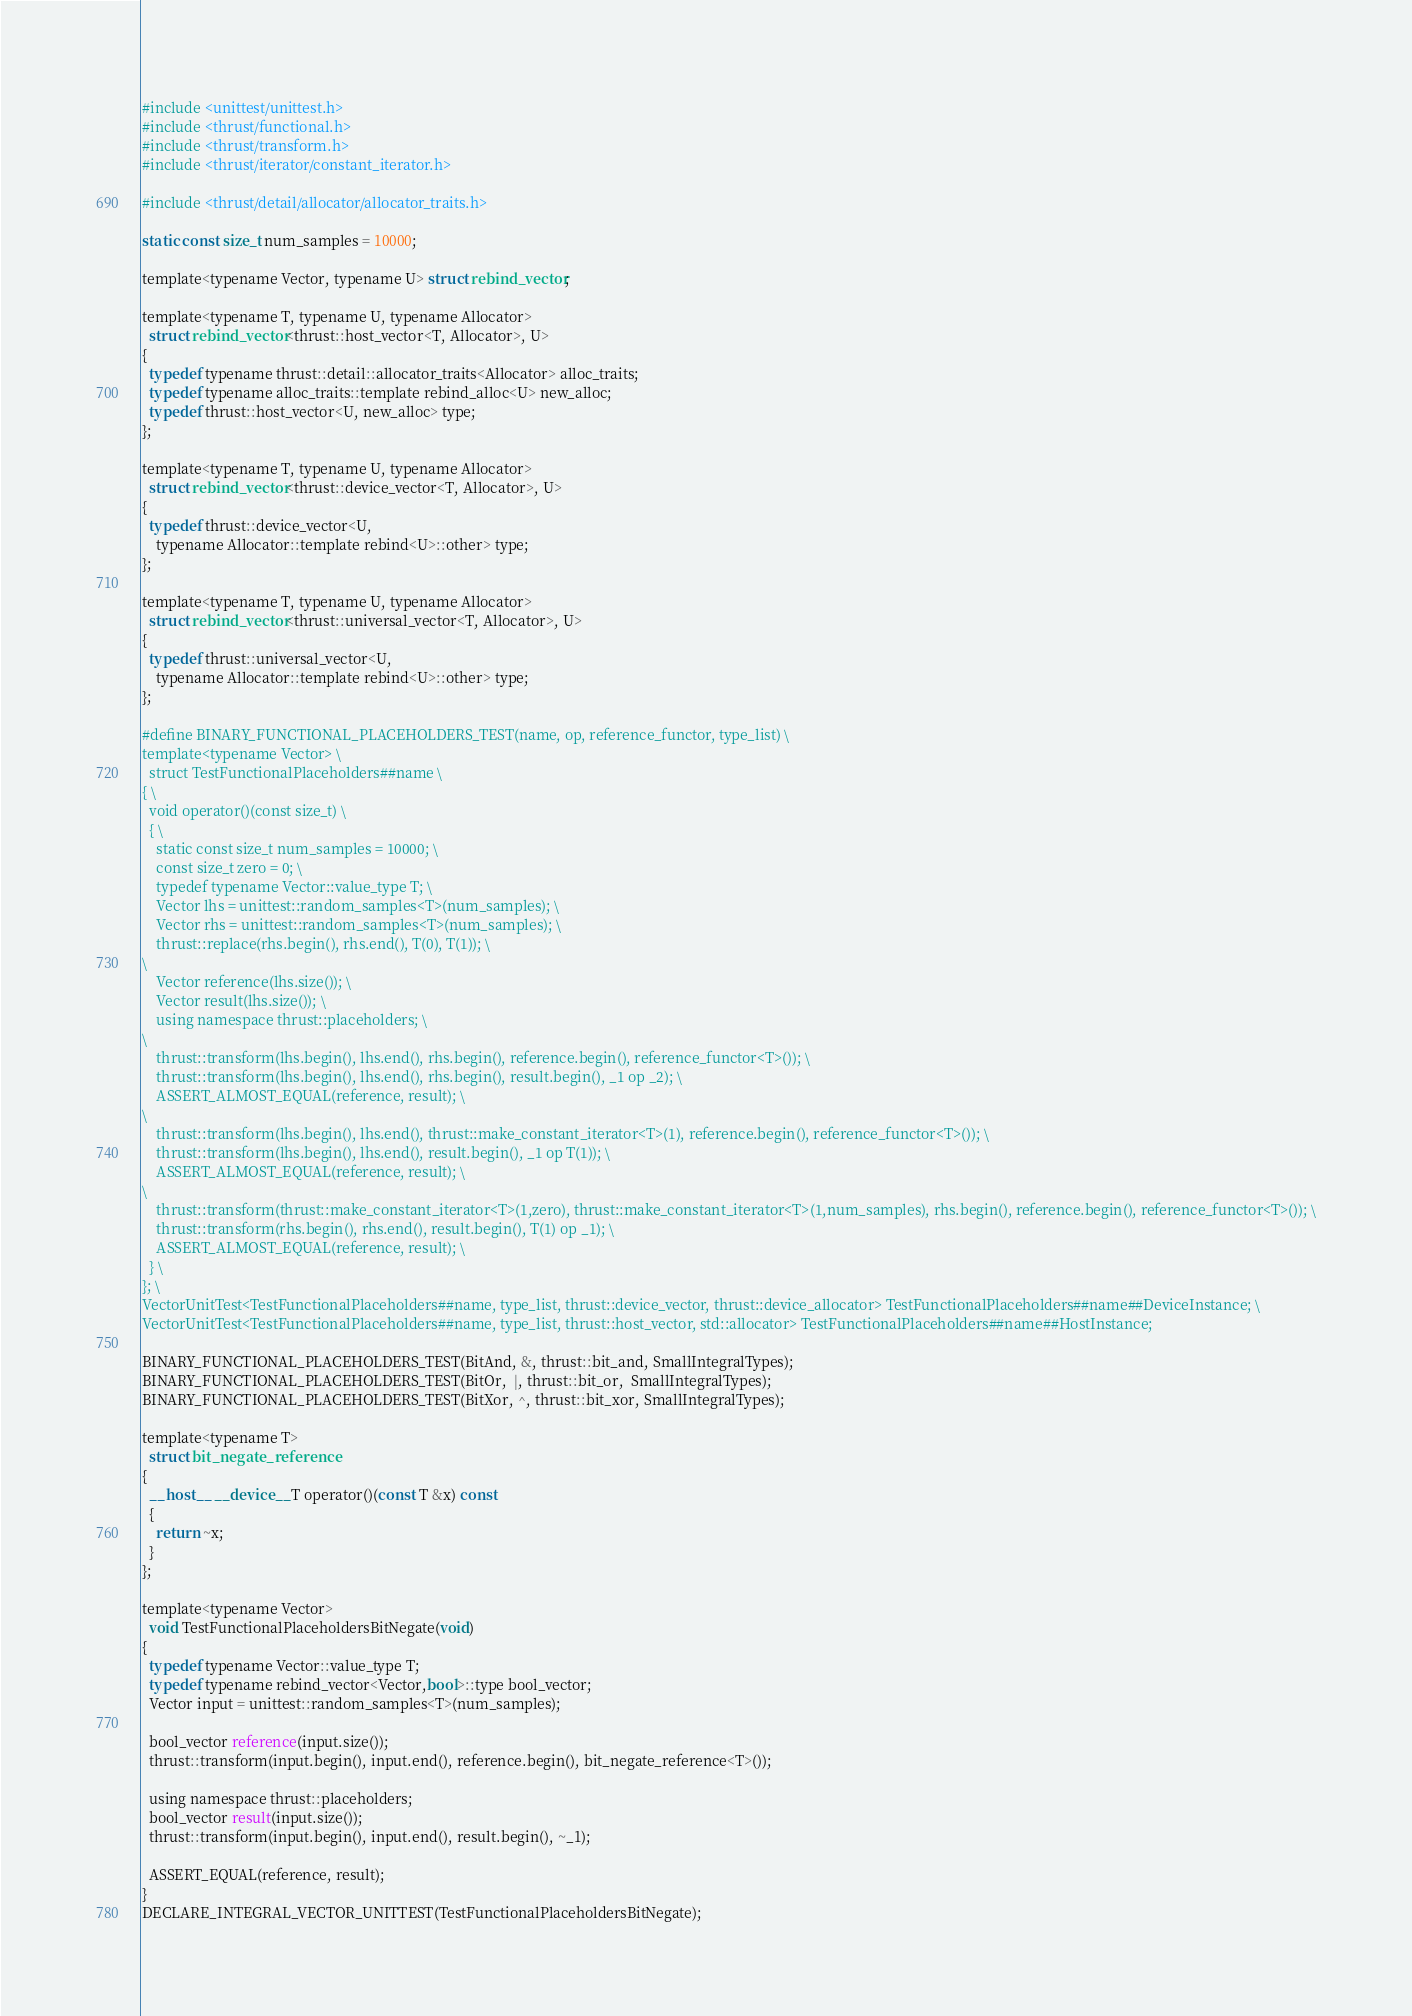<code> <loc_0><loc_0><loc_500><loc_500><_Cuda_>#include <unittest/unittest.h>
#include <thrust/functional.h>
#include <thrust/transform.h>
#include <thrust/iterator/constant_iterator.h>

#include <thrust/detail/allocator/allocator_traits.h>

static const size_t num_samples = 10000;

template<typename Vector, typename U> struct rebind_vector;

template<typename T, typename U, typename Allocator>
  struct rebind_vector<thrust::host_vector<T, Allocator>, U>
{
  typedef typename thrust::detail::allocator_traits<Allocator> alloc_traits;
  typedef typename alloc_traits::template rebind_alloc<U> new_alloc;
  typedef thrust::host_vector<U, new_alloc> type;
};

template<typename T, typename U, typename Allocator>
  struct rebind_vector<thrust::device_vector<T, Allocator>, U>
{
  typedef thrust::device_vector<U,
    typename Allocator::template rebind<U>::other> type;
};

template<typename T, typename U, typename Allocator>
  struct rebind_vector<thrust::universal_vector<T, Allocator>, U>
{
  typedef thrust::universal_vector<U,
    typename Allocator::template rebind<U>::other> type;
};

#define BINARY_FUNCTIONAL_PLACEHOLDERS_TEST(name, op, reference_functor, type_list) \
template<typename Vector> \
  struct TestFunctionalPlaceholders##name \
{ \
  void operator()(const size_t) \
  { \
    static const size_t num_samples = 10000; \
    const size_t zero = 0; \
    typedef typename Vector::value_type T; \
    Vector lhs = unittest::random_samples<T>(num_samples); \
    Vector rhs = unittest::random_samples<T>(num_samples); \
    thrust::replace(rhs.begin(), rhs.end(), T(0), T(1)); \
\
    Vector reference(lhs.size()); \
    Vector result(lhs.size()); \
    using namespace thrust::placeholders; \
\
    thrust::transform(lhs.begin(), lhs.end(), rhs.begin(), reference.begin(), reference_functor<T>()); \
    thrust::transform(lhs.begin(), lhs.end(), rhs.begin(), result.begin(), _1 op _2); \
    ASSERT_ALMOST_EQUAL(reference, result); \
\
    thrust::transform(lhs.begin(), lhs.end(), thrust::make_constant_iterator<T>(1), reference.begin(), reference_functor<T>()); \
    thrust::transform(lhs.begin(), lhs.end(), result.begin(), _1 op T(1)); \
    ASSERT_ALMOST_EQUAL(reference, result); \
\
    thrust::transform(thrust::make_constant_iterator<T>(1,zero), thrust::make_constant_iterator<T>(1,num_samples), rhs.begin(), reference.begin(), reference_functor<T>()); \
    thrust::transform(rhs.begin(), rhs.end(), result.begin(), T(1) op _1); \
    ASSERT_ALMOST_EQUAL(reference, result); \
  } \
}; \
VectorUnitTest<TestFunctionalPlaceholders##name, type_list, thrust::device_vector, thrust::device_allocator> TestFunctionalPlaceholders##name##DeviceInstance; \
VectorUnitTest<TestFunctionalPlaceholders##name, type_list, thrust::host_vector, std::allocator> TestFunctionalPlaceholders##name##HostInstance;

BINARY_FUNCTIONAL_PLACEHOLDERS_TEST(BitAnd, &, thrust::bit_and, SmallIntegralTypes);
BINARY_FUNCTIONAL_PLACEHOLDERS_TEST(BitOr,  |, thrust::bit_or,  SmallIntegralTypes);
BINARY_FUNCTIONAL_PLACEHOLDERS_TEST(BitXor, ^, thrust::bit_xor, SmallIntegralTypes);

template<typename T>
  struct bit_negate_reference
{
  __host__ __device__ T operator()(const T &x) const
  {
    return ~x;
  }
};

template<typename Vector>
  void TestFunctionalPlaceholdersBitNegate(void)
{
  typedef typename Vector::value_type T;
  typedef typename rebind_vector<Vector,bool>::type bool_vector;
  Vector input = unittest::random_samples<T>(num_samples);

  bool_vector reference(input.size());
  thrust::transform(input.begin(), input.end(), reference.begin(), bit_negate_reference<T>());

  using namespace thrust::placeholders;
  bool_vector result(input.size());
  thrust::transform(input.begin(), input.end(), result.begin(), ~_1);

  ASSERT_EQUAL(reference, result);
}
DECLARE_INTEGRAL_VECTOR_UNITTEST(TestFunctionalPlaceholdersBitNegate);

</code> 